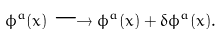Convert formula to latex. <formula><loc_0><loc_0><loc_500><loc_500>\phi ^ { a } ( x ) \longrightarrow \phi ^ { a } ( x ) + \delta \phi ^ { a } ( x ) .</formula> 